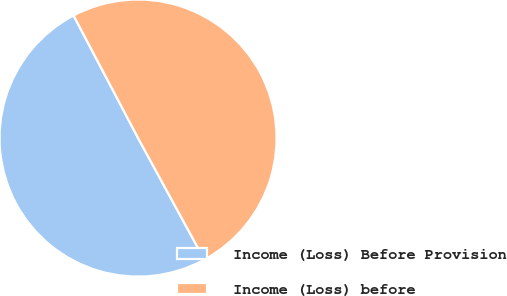<chart> <loc_0><loc_0><loc_500><loc_500><pie_chart><fcel>Income (Loss) Before Provision<fcel>Income (Loss) before<nl><fcel>50.23%<fcel>49.77%<nl></chart> 